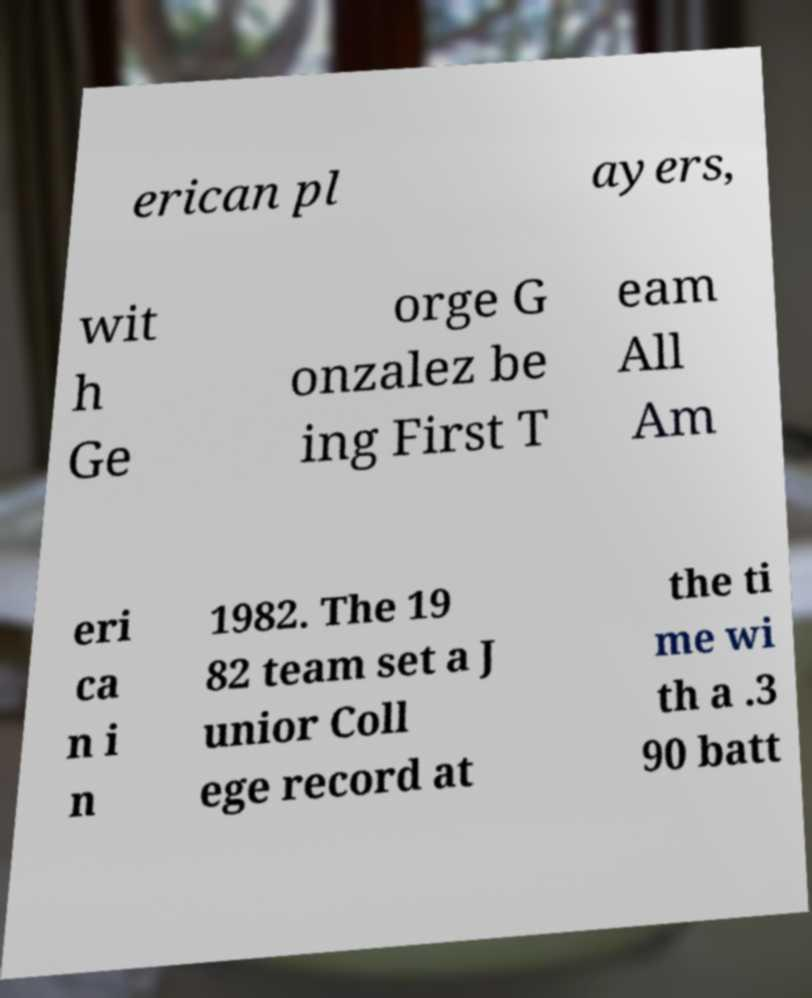There's text embedded in this image that I need extracted. Can you transcribe it verbatim? erican pl ayers, wit h Ge orge G onzalez be ing First T eam All Am eri ca n i n 1982. The 19 82 team set a J unior Coll ege record at the ti me wi th a .3 90 batt 